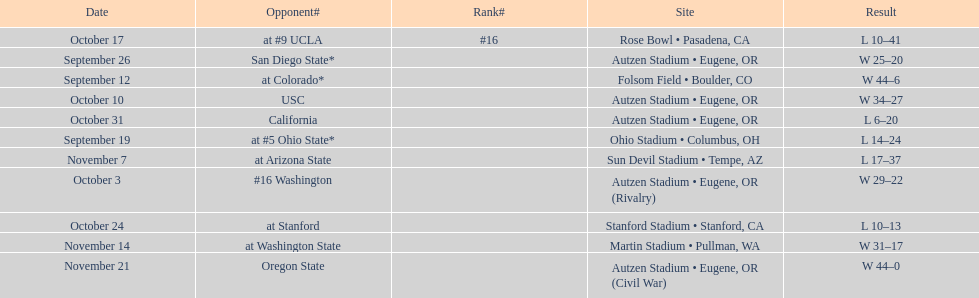Were the results of the game of november 14 above or below the results of the october 17 game? Above. 